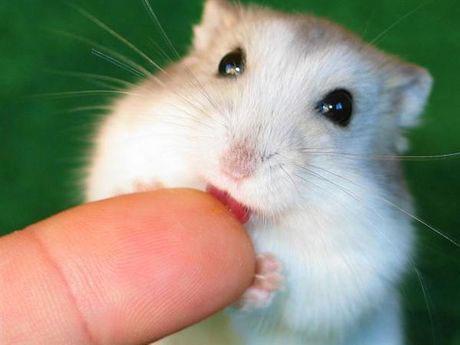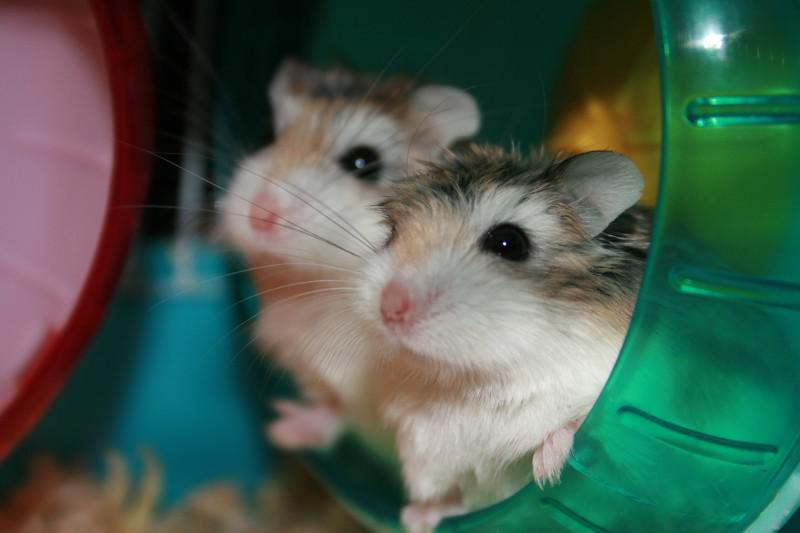The first image is the image on the left, the second image is the image on the right. For the images shown, is this caption "In both images, two hamsters are touching each other." true? Answer yes or no. No. The first image is the image on the left, the second image is the image on the right. Considering the images on both sides, is "A human finger is in an image with no more than two hamsters." valid? Answer yes or no. Yes. 